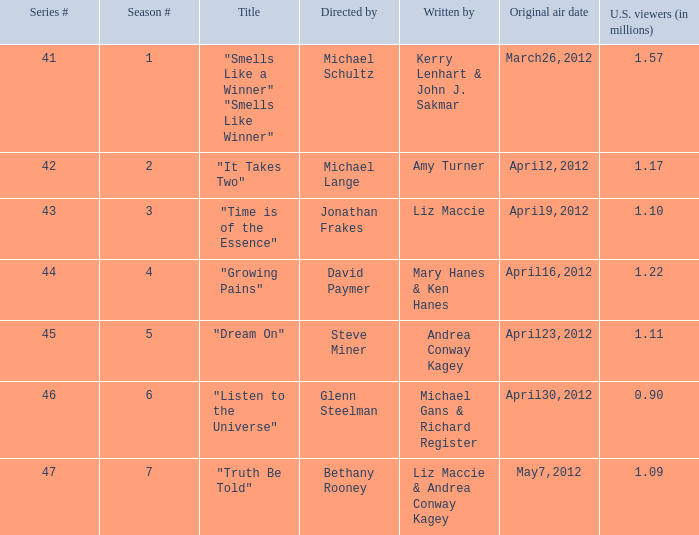What is the name of the episodes which had 1.22 million U.S. viewers? "Growing Pains". 